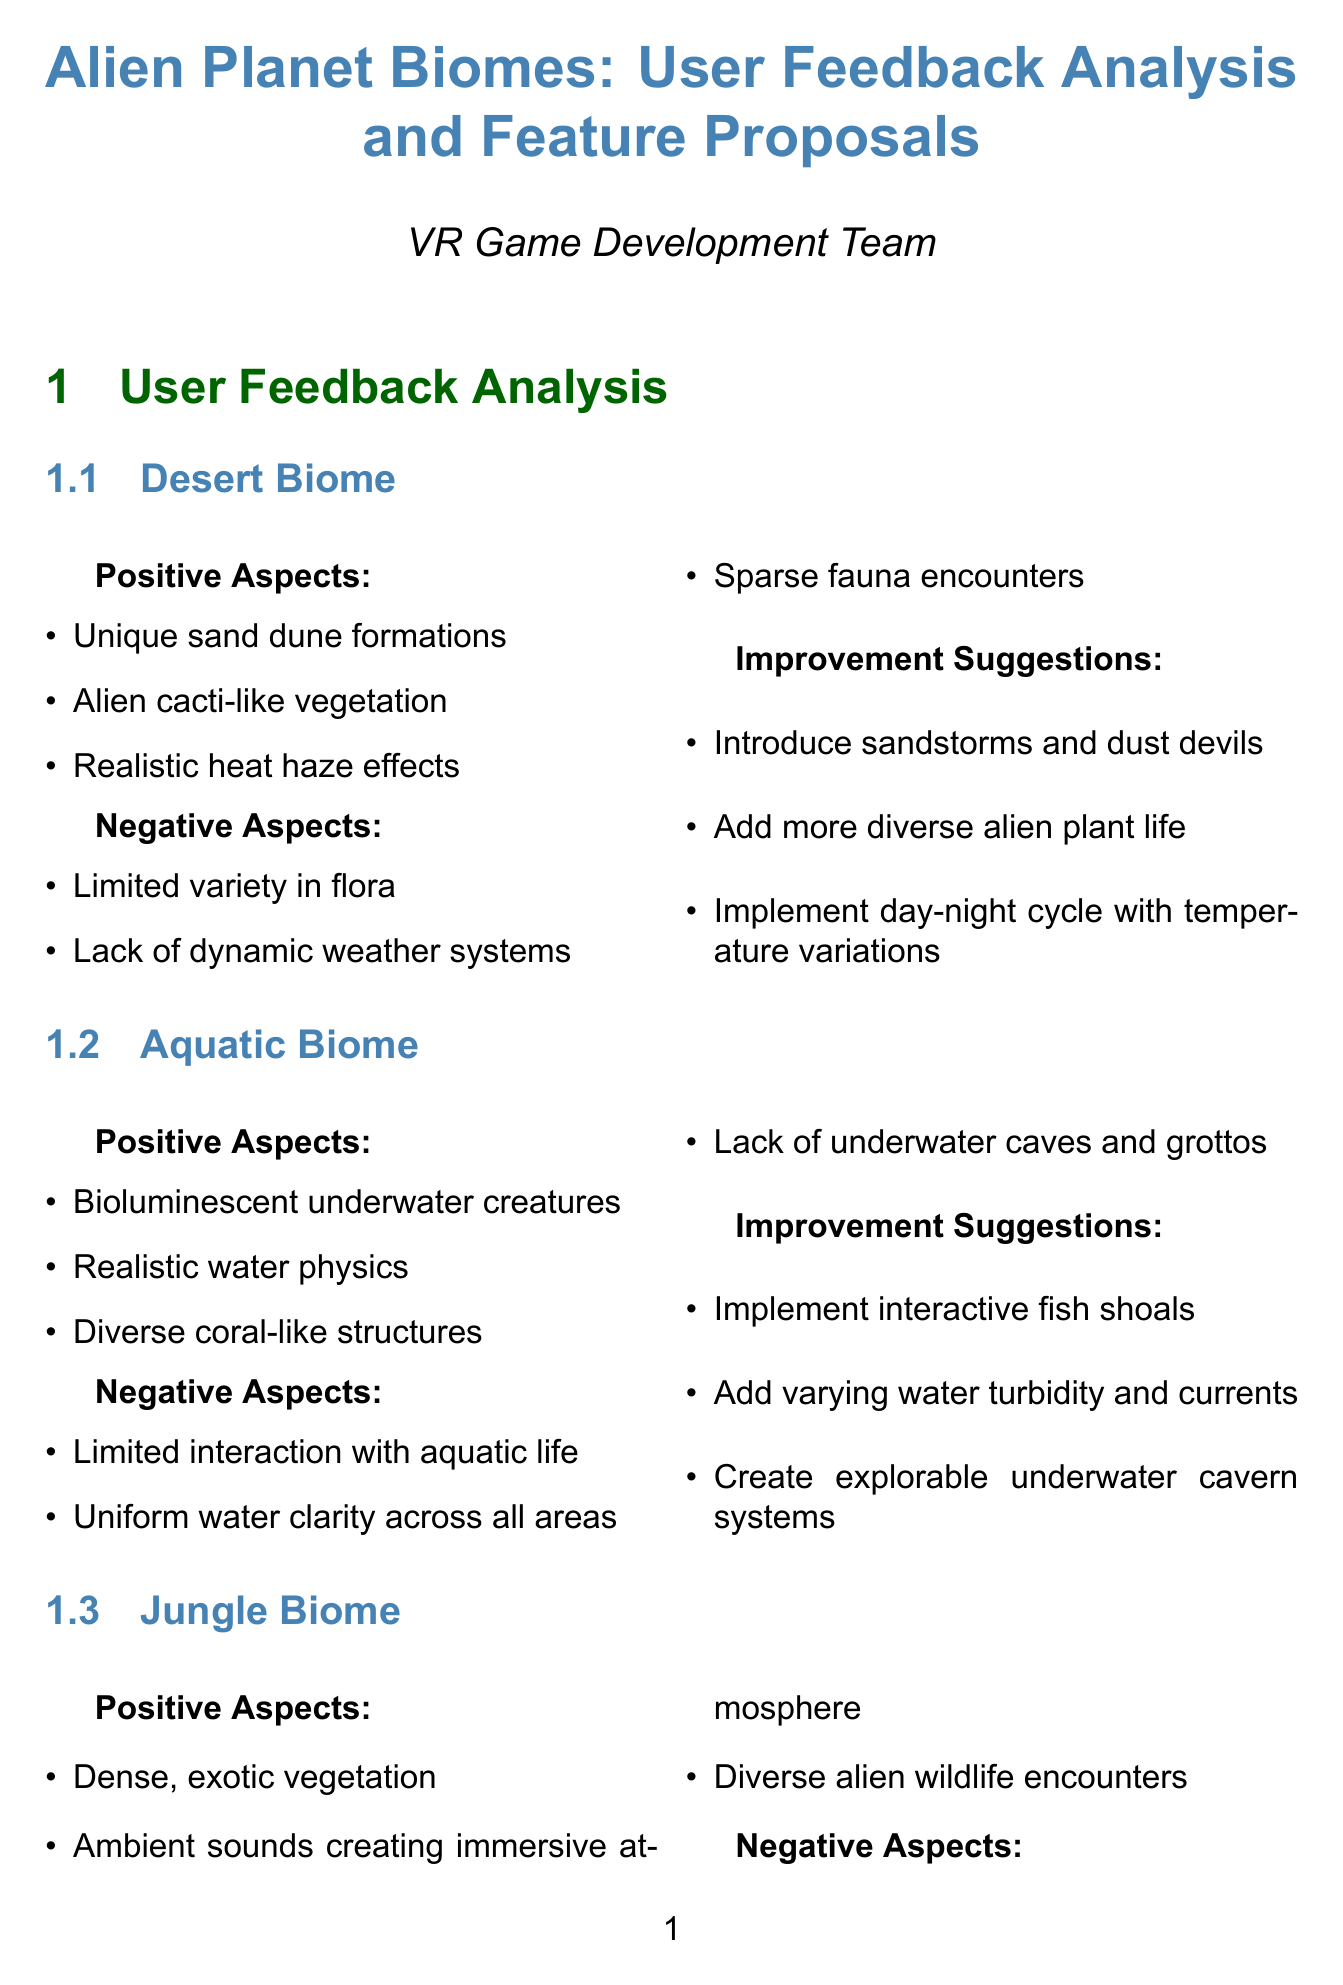What are the positive aspects of the desert biome? The positive aspects are listed under the desert biome section of the document, including unique sand dune formations, alien cacti-like vegetation, and realistic heat haze effects.
Answer: Unique sand dune formations, alien cacti-like vegetation, realistic heat haze effects What is one suggested improvement for the aquatic biome? The improvement suggestions for the aquatic biome can be found in its respective section, which recommends implementing interactive fish shoals.
Answer: Implement interactive fish shoals What is the description of the adaptive ecosystem feature? The description of the adaptive ecosystem feature is found in the new feature proposals section, detailing its dynamic ecosystem nature.
Answer: Implement a dynamic ecosystem where player actions affect the balance of alien flora and fauna What performance optimization that should be implemented? The technical considerations section states multiple performance optimizations, one of which is to implement a level of detail (LOD) system for complex alien flora.
Answer: Implement level of detail (LOD) system for complex alien flora How many competing titles are mentioned in the market analysis? The market analysis section discusses two competing titles, detailing their strengths and weaknesses.
Answer: Two What is a potential benefit of introducing extreme weather events? The potential benefits of extreme weather events are included in the new feature proposals, mentioning added challenge and excitement as one of the benefits.
Answer: Added challenge and excitement What are the target audiences for the game? The target audience section identifies several audience categories, focusing on VR enthusiasts and sci-fi fans, which are explicitly mentioned.
Answer: VR enthusiasts seeking immersive alien experiences, sci-fi fans interested in exploring extraterrestrial environments, gamers looking for unique and visually stunning VR content What is one weakness of Subnautica VR? Under the competing titles section, a weakness of Subnautica VR is mentioned, which is limited to a single biome type.
Answer: Limited to a single biome type 